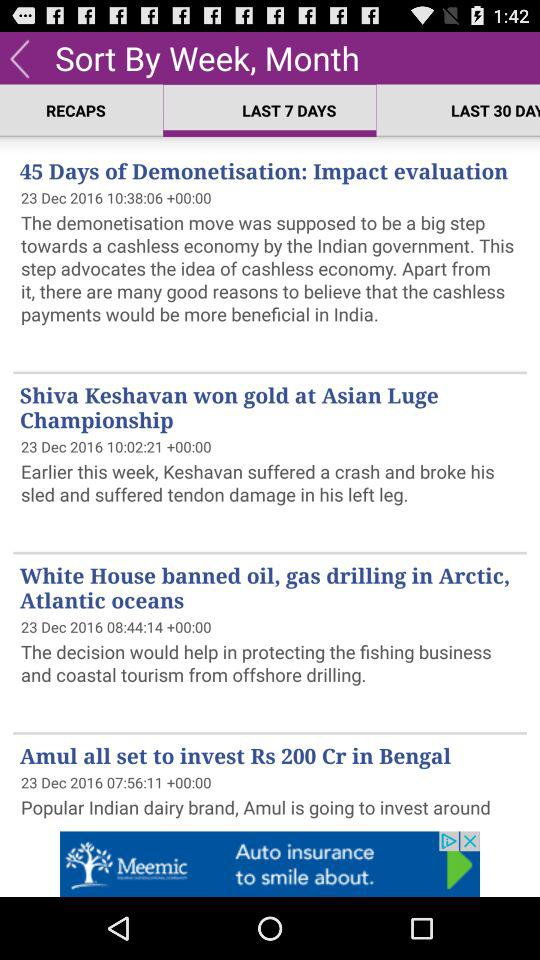What option is selected? The selected option is "LAST 7 DAYS". 